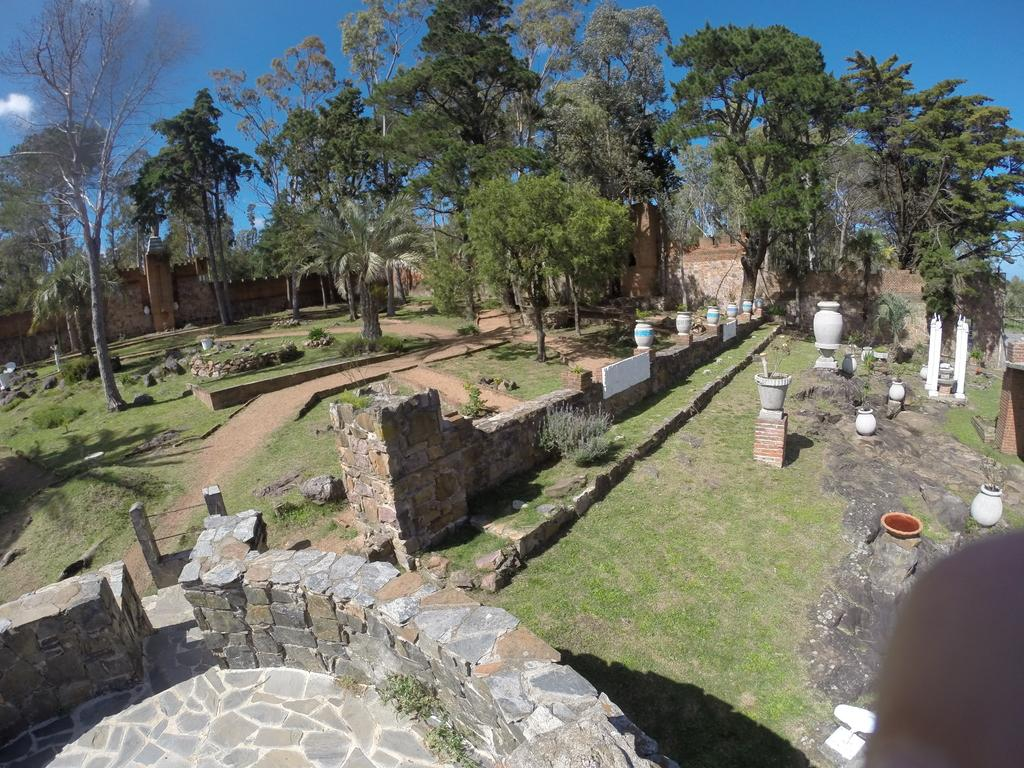What type of vegetation can be seen in the image? There is grass and plants visible in the image. What type of structures are present in the image? There are stone walls, pots, pillars, and walkways in the image. What type of natural elements can be seen in the image? There are trees in the image. What can be seen in the background of the image? The background of the image includes walls and sky. How many bells are hanging from the trees in the image? There are no bells present in the image. What type of icicle can be seen on the walkways in the image? There are no icicles present in the image. 